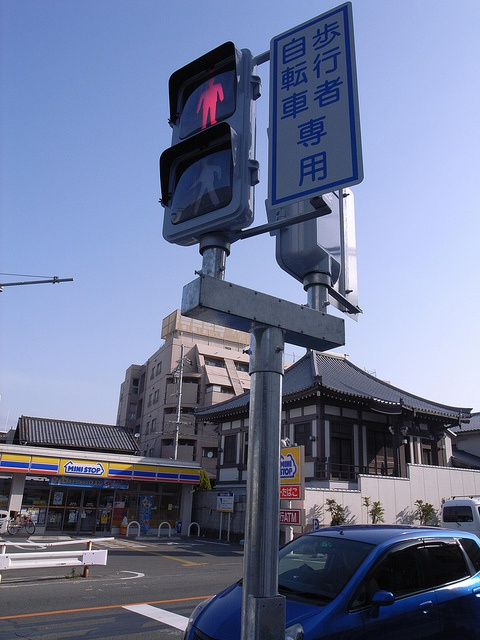Describe the objects in this image and their specific colors. I can see car in gray, black, navy, and darkblue tones, traffic light in gray, black, navy, darkblue, and darkgray tones, and bicycle in gray, black, and maroon tones in this image. 